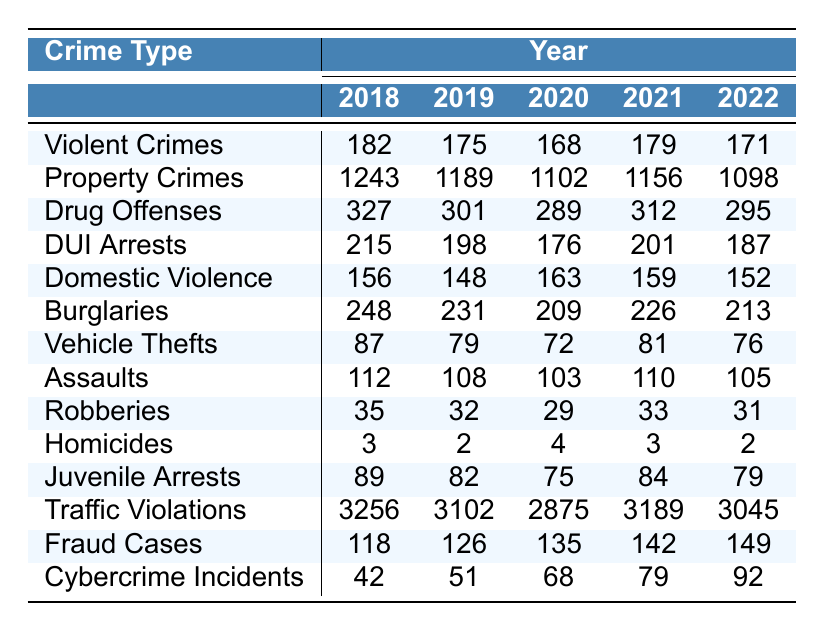What was the total number of violent crimes reported in 2020? In the table, the value for violent crimes in 2020 is directly listed as 168.
Answer: 168 Which year saw the highest number of property crimes? By reviewing the property crimes data across the years, 2018 shows the highest value of 1243.
Answer: 2018 What was the average number of drug offenses from 2018 to 2022? The sum of drug offenses from 2018 to 2022 is (327 + 301 + 289 + 312 + 295) = 1524. There are 5 years, so the average is 1524 / 5 = 304.8.
Answer: 304.8 Did the number of homicides increase from 2019 to 2020? In 2019 there were 2 homicides and in 2020 there were 4. Since 4 is greater than 2, it indicates an increase.
Answer: Yes What is the percentage decrease in DUI arrests from 2018 to 2022? DUI arrests in 2018 were 215 and in 2022 were 187. The decrease is 215 - 187 = 28. To find the percentage decrease, calculate (28 / 215) * 100, which equals approximately 13.02%.
Answer: 13.02% Which year had the least number of burglaries? The burglaries values across the years show that the lowest number occurs in 2020, which is 209.
Answer: 2020 How many more traffic violations were reported in 2021 compared to 2020? The values indicate that 3189 traffic violations occurred in 2021 and 2875 in 2020. The difference is 3189 - 2875 = 314.
Answer: 314 What was the trend in juvenile arrests from 2018 to 2022? The juveniles arrested decreased from 89 in 2018 to 79 in 2022, showing a downward trend overall over the years.
Answer: Downward trend How many property crimes were there in 2021 and how does it compare to 2019? In 2021, there were 1156 property crimes, and in 2019 there were 1189. This shows a decrease of 33 incidents from 2019 to 2021 (1189 - 1156 = 33).
Answer: 1156, decrease of 33 Was there an increase in cybercrime incidents every year from 2018 to 2022? The cybercrime incidents from 2018 to 2022 were: 42, 51, 68, 79, and 92. Each year shows an increase from the previous year, indicating a consistent rise in incidents.
Answer: Yes 